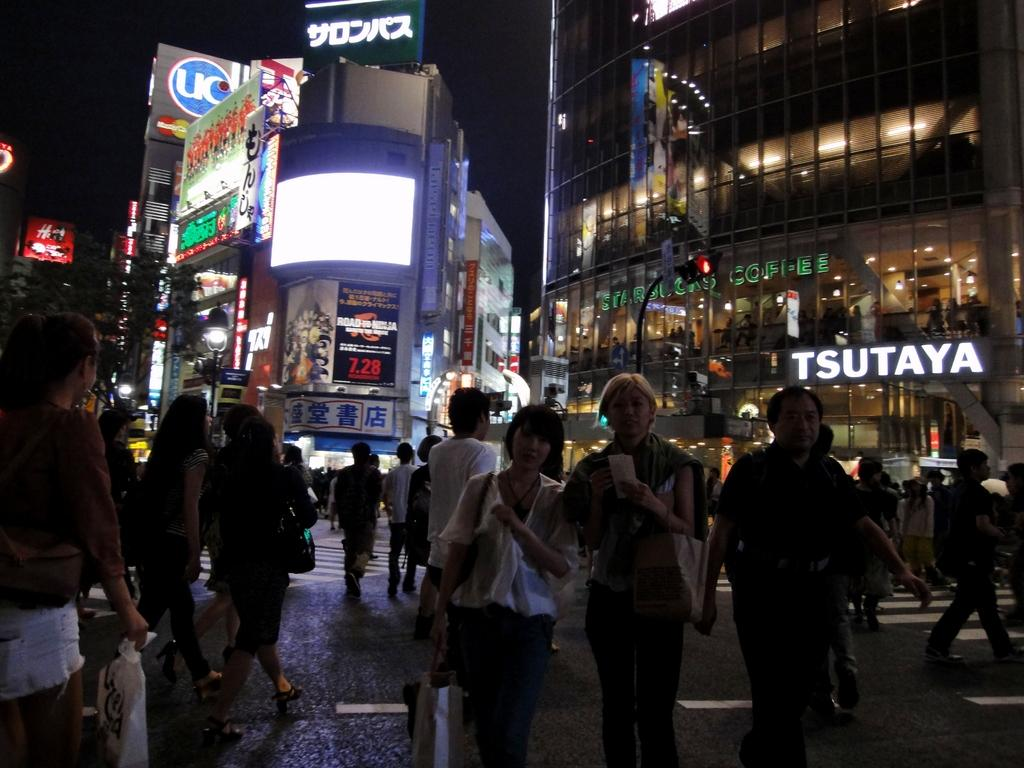Where was the image taken? The image was taken on a road. What is happening on the road in the image? There are many people walking on the road. What can be seen in the background of the image? There are buildings in the background of the image. What type of buildings are they? The buildings contain shops. What is used to control traffic in the image? There is a traffic signal in the image. What type of plant is being used as a weapon in the battle depicted in the image? There is no battle or plant being used as a weapon in the image; it shows people walking on a road with buildings and a traffic signal in the background. 